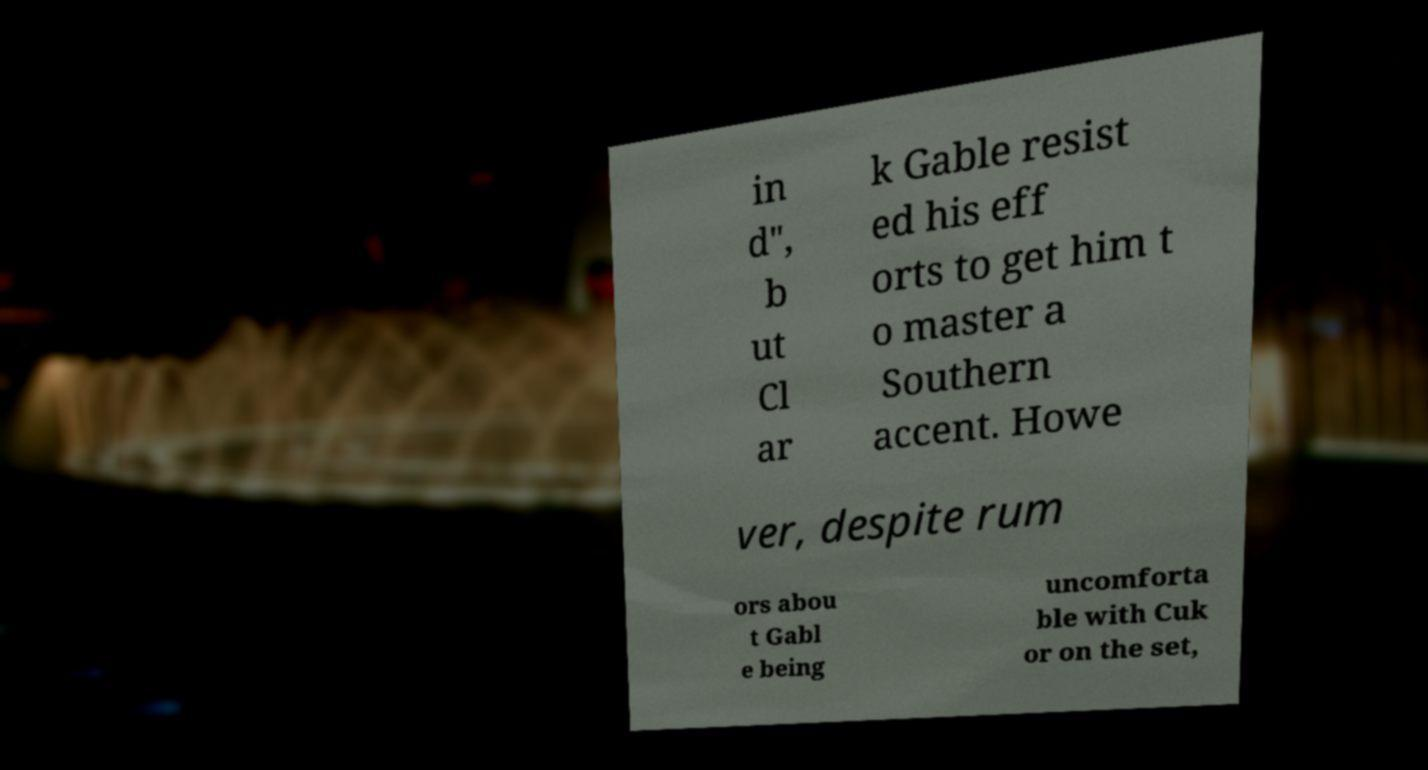There's text embedded in this image that I need extracted. Can you transcribe it verbatim? in d", b ut Cl ar k Gable resist ed his eff orts to get him t o master a Southern accent. Howe ver, despite rum ors abou t Gabl e being uncomforta ble with Cuk or on the set, 